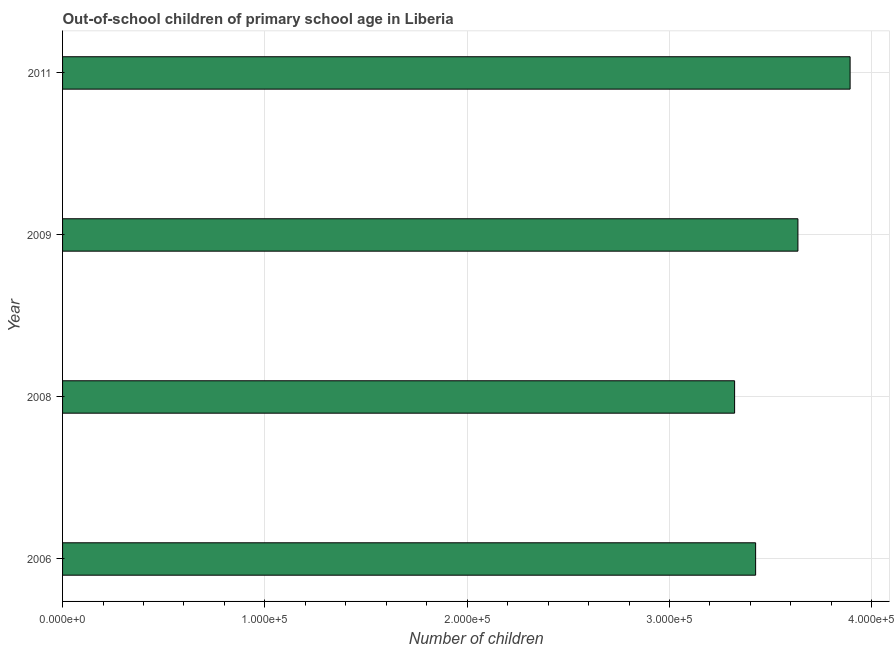Does the graph contain any zero values?
Your response must be concise. No. What is the title of the graph?
Make the answer very short. Out-of-school children of primary school age in Liberia. What is the label or title of the X-axis?
Give a very brief answer. Number of children. What is the label or title of the Y-axis?
Offer a terse response. Year. What is the number of out-of-school children in 2008?
Your response must be concise. 3.32e+05. Across all years, what is the maximum number of out-of-school children?
Your answer should be compact. 3.89e+05. Across all years, what is the minimum number of out-of-school children?
Your response must be concise. 3.32e+05. What is the sum of the number of out-of-school children?
Keep it short and to the point. 1.43e+06. What is the difference between the number of out-of-school children in 2008 and 2011?
Give a very brief answer. -5.71e+04. What is the average number of out-of-school children per year?
Ensure brevity in your answer.  3.57e+05. What is the median number of out-of-school children?
Your answer should be very brief. 3.53e+05. In how many years, is the number of out-of-school children greater than 180000 ?
Your answer should be compact. 4. What is the ratio of the number of out-of-school children in 2008 to that in 2011?
Your response must be concise. 0.85. Is the number of out-of-school children in 2008 less than that in 2011?
Make the answer very short. Yes. Is the difference between the number of out-of-school children in 2006 and 2009 greater than the difference between any two years?
Provide a short and direct response. No. What is the difference between the highest and the second highest number of out-of-school children?
Make the answer very short. 2.58e+04. Is the sum of the number of out-of-school children in 2008 and 2011 greater than the maximum number of out-of-school children across all years?
Offer a terse response. Yes. What is the difference between the highest and the lowest number of out-of-school children?
Provide a short and direct response. 5.71e+04. How many bars are there?
Keep it short and to the point. 4. Are all the bars in the graph horizontal?
Provide a short and direct response. Yes. What is the difference between two consecutive major ticks on the X-axis?
Your response must be concise. 1.00e+05. Are the values on the major ticks of X-axis written in scientific E-notation?
Offer a very short reply. Yes. What is the Number of children in 2006?
Ensure brevity in your answer.  3.43e+05. What is the Number of children in 2008?
Offer a terse response. 3.32e+05. What is the Number of children in 2009?
Provide a succinct answer. 3.63e+05. What is the Number of children of 2011?
Provide a short and direct response. 3.89e+05. What is the difference between the Number of children in 2006 and 2008?
Ensure brevity in your answer.  1.04e+04. What is the difference between the Number of children in 2006 and 2009?
Ensure brevity in your answer.  -2.09e+04. What is the difference between the Number of children in 2006 and 2011?
Your response must be concise. -4.67e+04. What is the difference between the Number of children in 2008 and 2009?
Your response must be concise. -3.13e+04. What is the difference between the Number of children in 2008 and 2011?
Ensure brevity in your answer.  -5.71e+04. What is the difference between the Number of children in 2009 and 2011?
Your answer should be compact. -2.58e+04. What is the ratio of the Number of children in 2006 to that in 2008?
Your response must be concise. 1.03. What is the ratio of the Number of children in 2006 to that in 2009?
Provide a succinct answer. 0.94. What is the ratio of the Number of children in 2006 to that in 2011?
Offer a terse response. 0.88. What is the ratio of the Number of children in 2008 to that in 2009?
Make the answer very short. 0.91. What is the ratio of the Number of children in 2008 to that in 2011?
Keep it short and to the point. 0.85. What is the ratio of the Number of children in 2009 to that in 2011?
Your answer should be very brief. 0.93. 